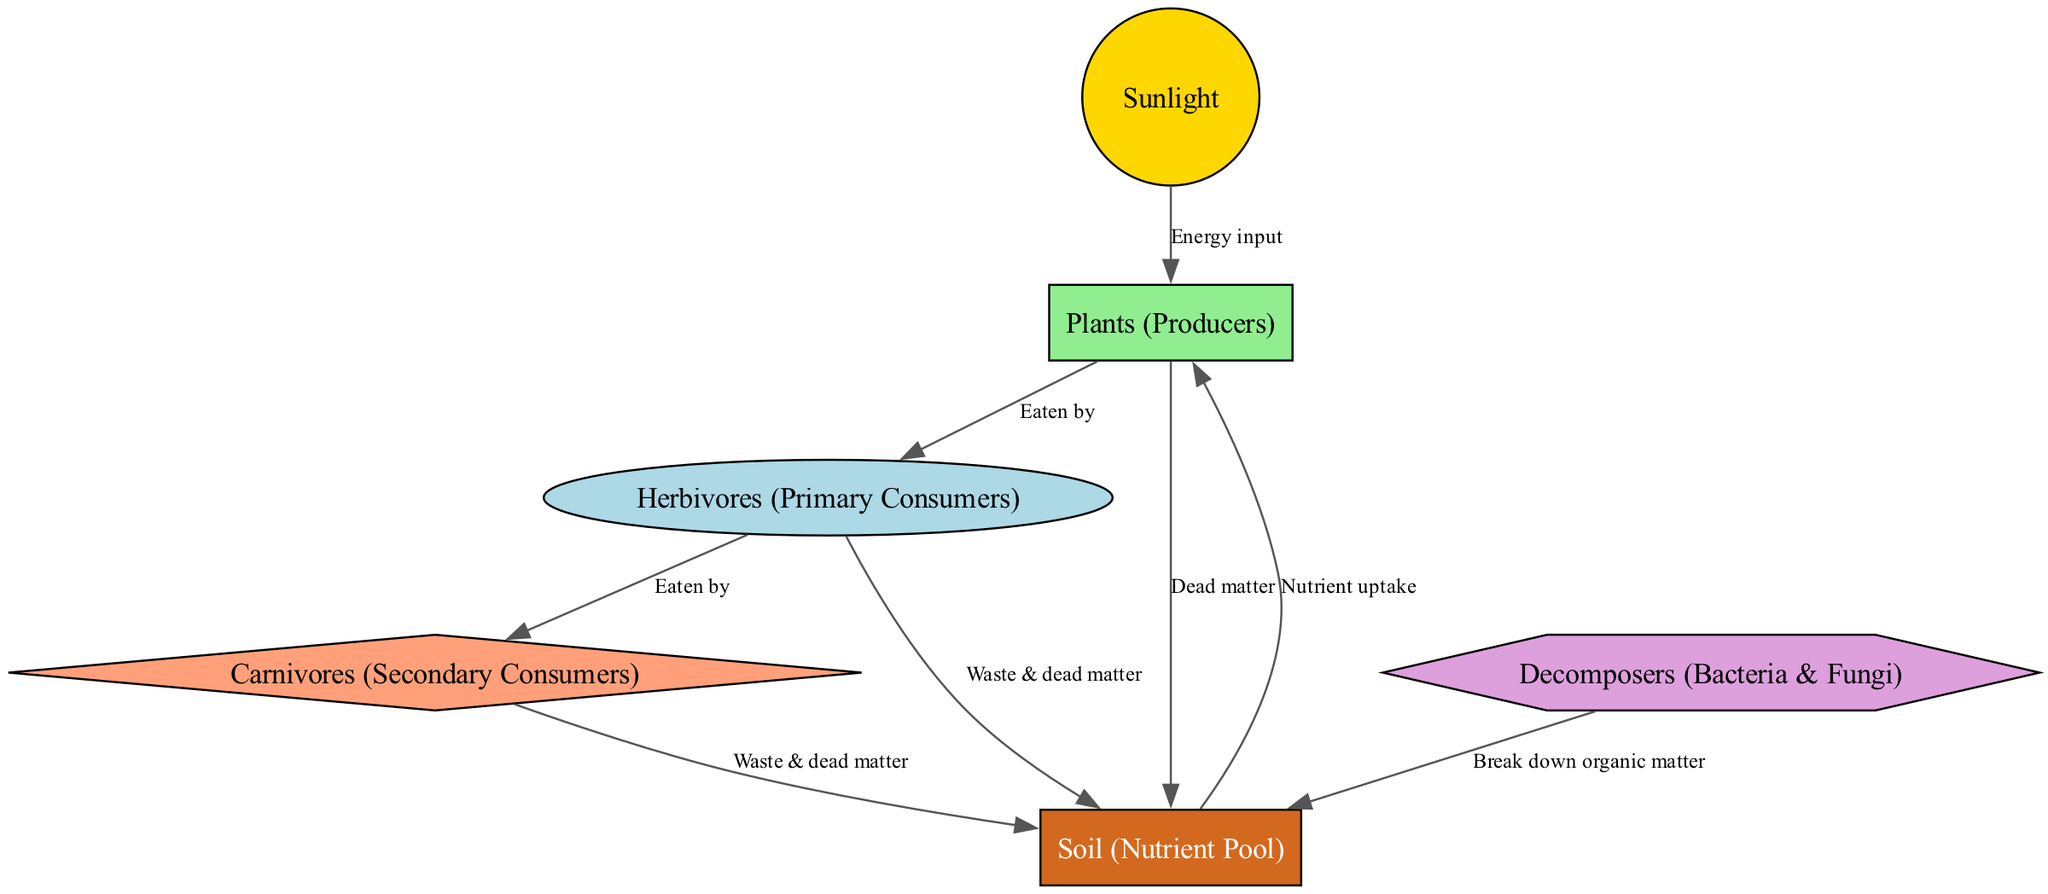What are the producers in this ecosystem? According to the diagram, the producers are represented by the node labeled "Plants". This can be identified as the only node linked to sunlight as its energy source.
Answer: Plants (Producers) How many nodes are present in the diagram? The diagram contains a total of six distinct nodes: sunlight, plants, herbivores, carnivores, decomposers, and soil. This can be confirmed by counting each unique node listed.
Answer: 6 What energy input do plants receive in the nutrient cycle? The diagram clearly shows that "Sunlight" serves as the energy input for "Plants". This connection is indicated by the directed edge labeled "Energy input".
Answer: Sunlight What do herbivores contribute to the soil? The diagram indicates that herbivores contribute "Waste & dead matter" to the soil. This relationship is represented by the directed edge from herbivores to soil labeled accordingly.
Answer: Waste & dead matter What is the role of decomposers in the nutrient cycle? The role of decomposers is to "Break down organic matter." This can be deduced from the direct connection between decomposers and soil, where this function is noted on the edge.
Answer: Break down organic matter Which node receives nutrients from the soil? The diagram illustrates that "Plants" receive nutrients from the "Soil". This is evidenced by the arrow pointing from the soil to the plants, which is labeled "Nutrient uptake".
Answer: Plants What is the relationship between herbivores and carnivores? The edge labeled "Eaten by" indicates that herbivores are consumed by carnivores. This shows a direct pathway of energy transfer from one consumer level to the next.
Answer: Eaten by In total, how many different relationships are depicted by the edges in the diagram? There are a total of seven edges connecting the nodes, which represents the different relationships between them as illustrated in the diagram.
Answer: 7 Which groups contribute to the soil ecosystem? Three groups contribute to the soil: "Plants" (through dead matter), "Herbivores" (through waste and dead matter), and "Carnivores" (also through waste and dead matter). This relationship can be traced back through the respective edges leading to the soil.
Answer: Plants, Herbivores, Carnivores 